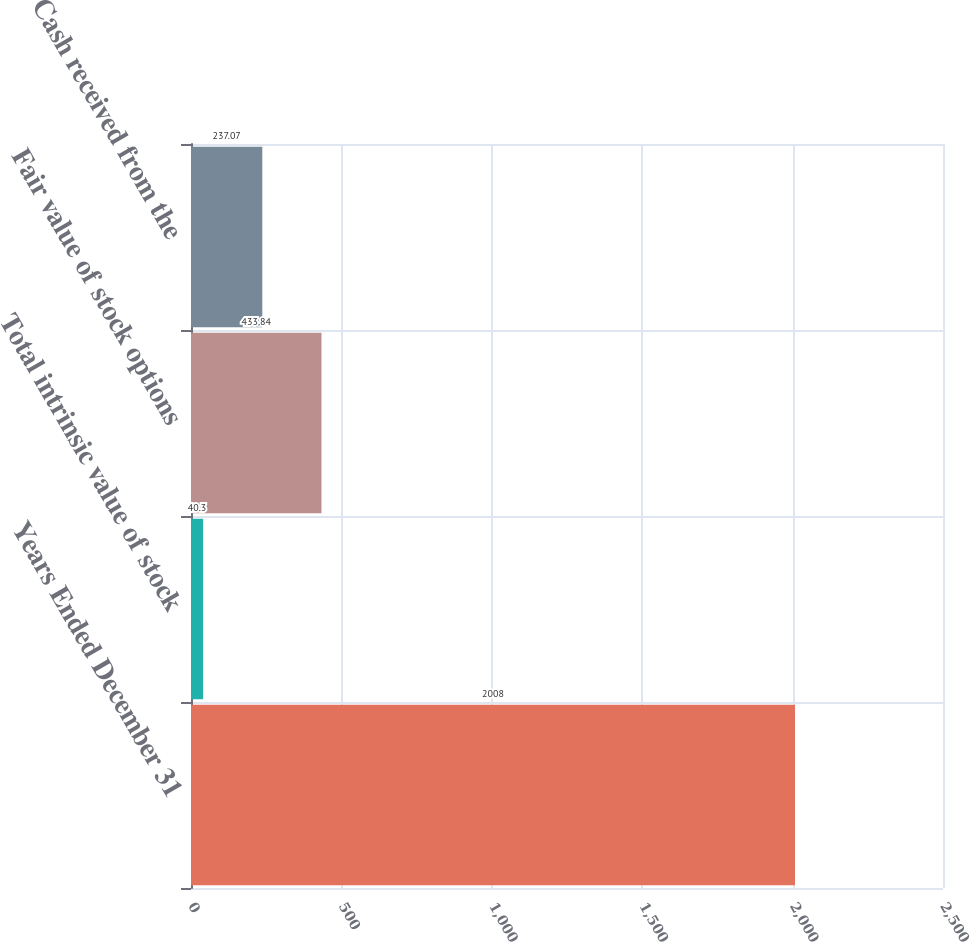Convert chart to OTSL. <chart><loc_0><loc_0><loc_500><loc_500><bar_chart><fcel>Years Ended December 31<fcel>Total intrinsic value of stock<fcel>Fair value of stock options<fcel>Cash received from the<nl><fcel>2008<fcel>40.3<fcel>433.84<fcel>237.07<nl></chart> 